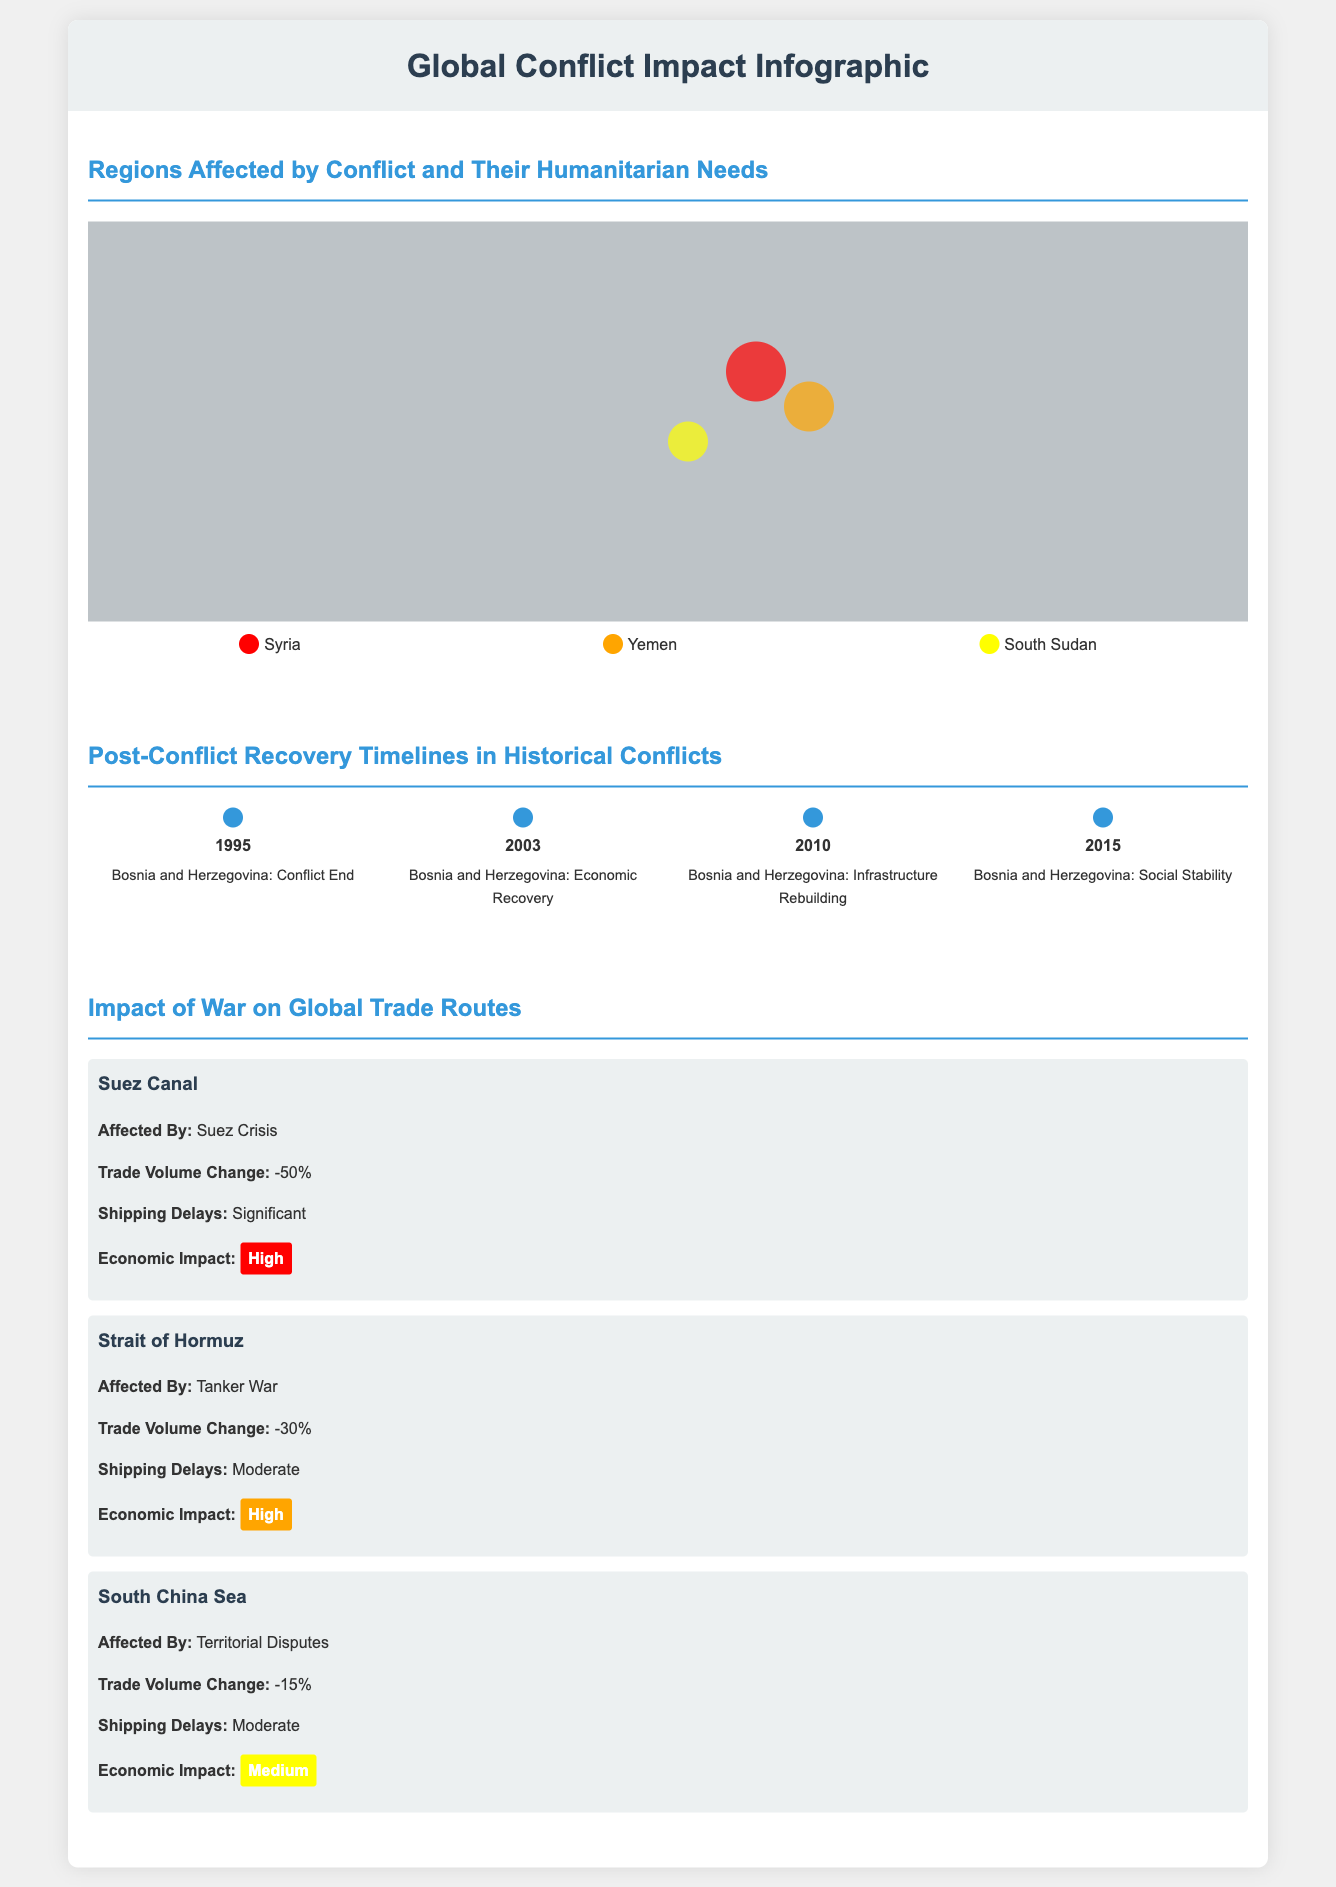What regions are highlighted as affected by conflict? The infographic identifies Syria, Yemen, and South Sudan as regions affected by conflict.
Answer: Syria, Yemen, South Sudan What year did the conflict in Bosnia and Herzegovina end? The timeline indicates that the conflict in Bosnia and Herzegovina ended in 1995.
Answer: 1995 What is the trade volume change for the Suez Canal? The document states that the trade volume change for the Suez Canal is -50%.
Answer: -50% Which region shows a moderate shipping delay? The trade route for the Strait of Hormuz indicates a moderate shipping delay.
Answer: Strait of Hormuz How many years did it take Bosnia and Herzegovina to achieve social stability after the conflict? Social stability in Bosnia and Herzegovina was achieved in 2015, which is 20 years after the conflict ended in 1995.
Answer: 20 years What color represents Yemen in the humanitarian needs map? The infographic uses orange to represent Yemen in the humanitarian needs map.
Answer: Orange Which trade route is affected by territorial disputes? The trade route indicated as being affected by territorial disputes is the South China Sea.
Answer: South China Sea What significant economic impact level is associated with the South China Sea? The document states that the economic impact for the South China Sea is medium.
Answer: Medium 